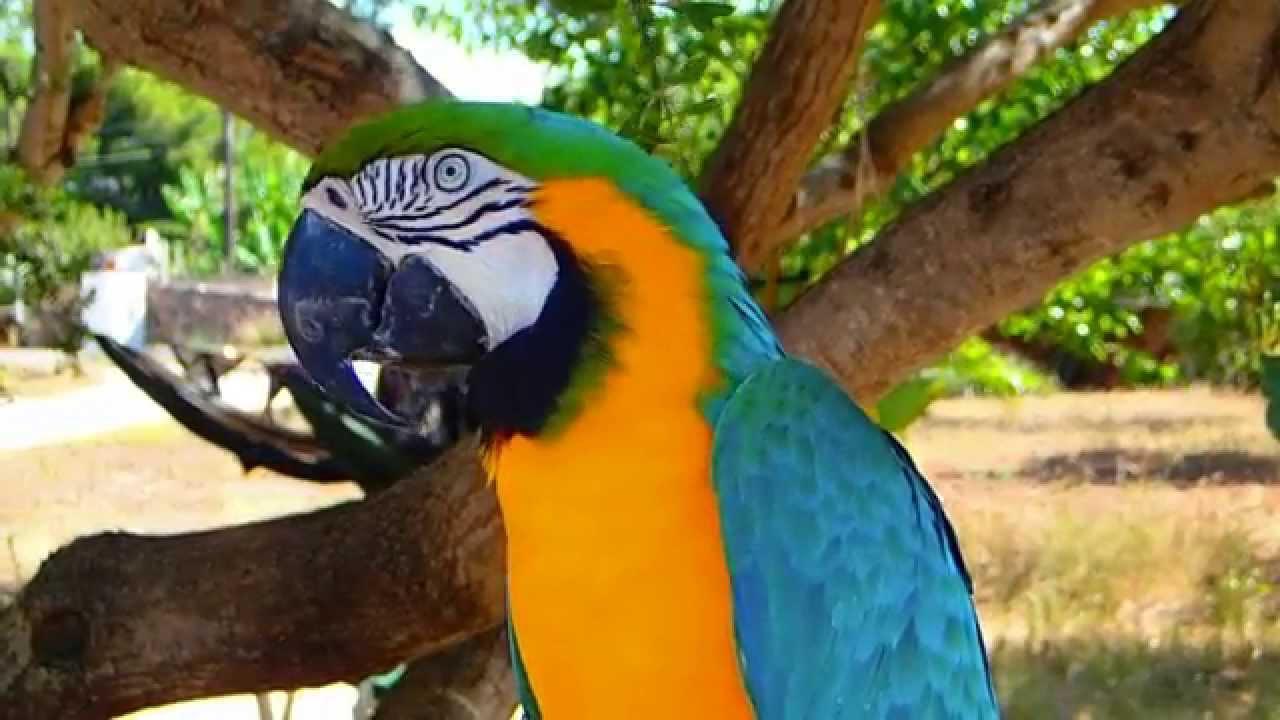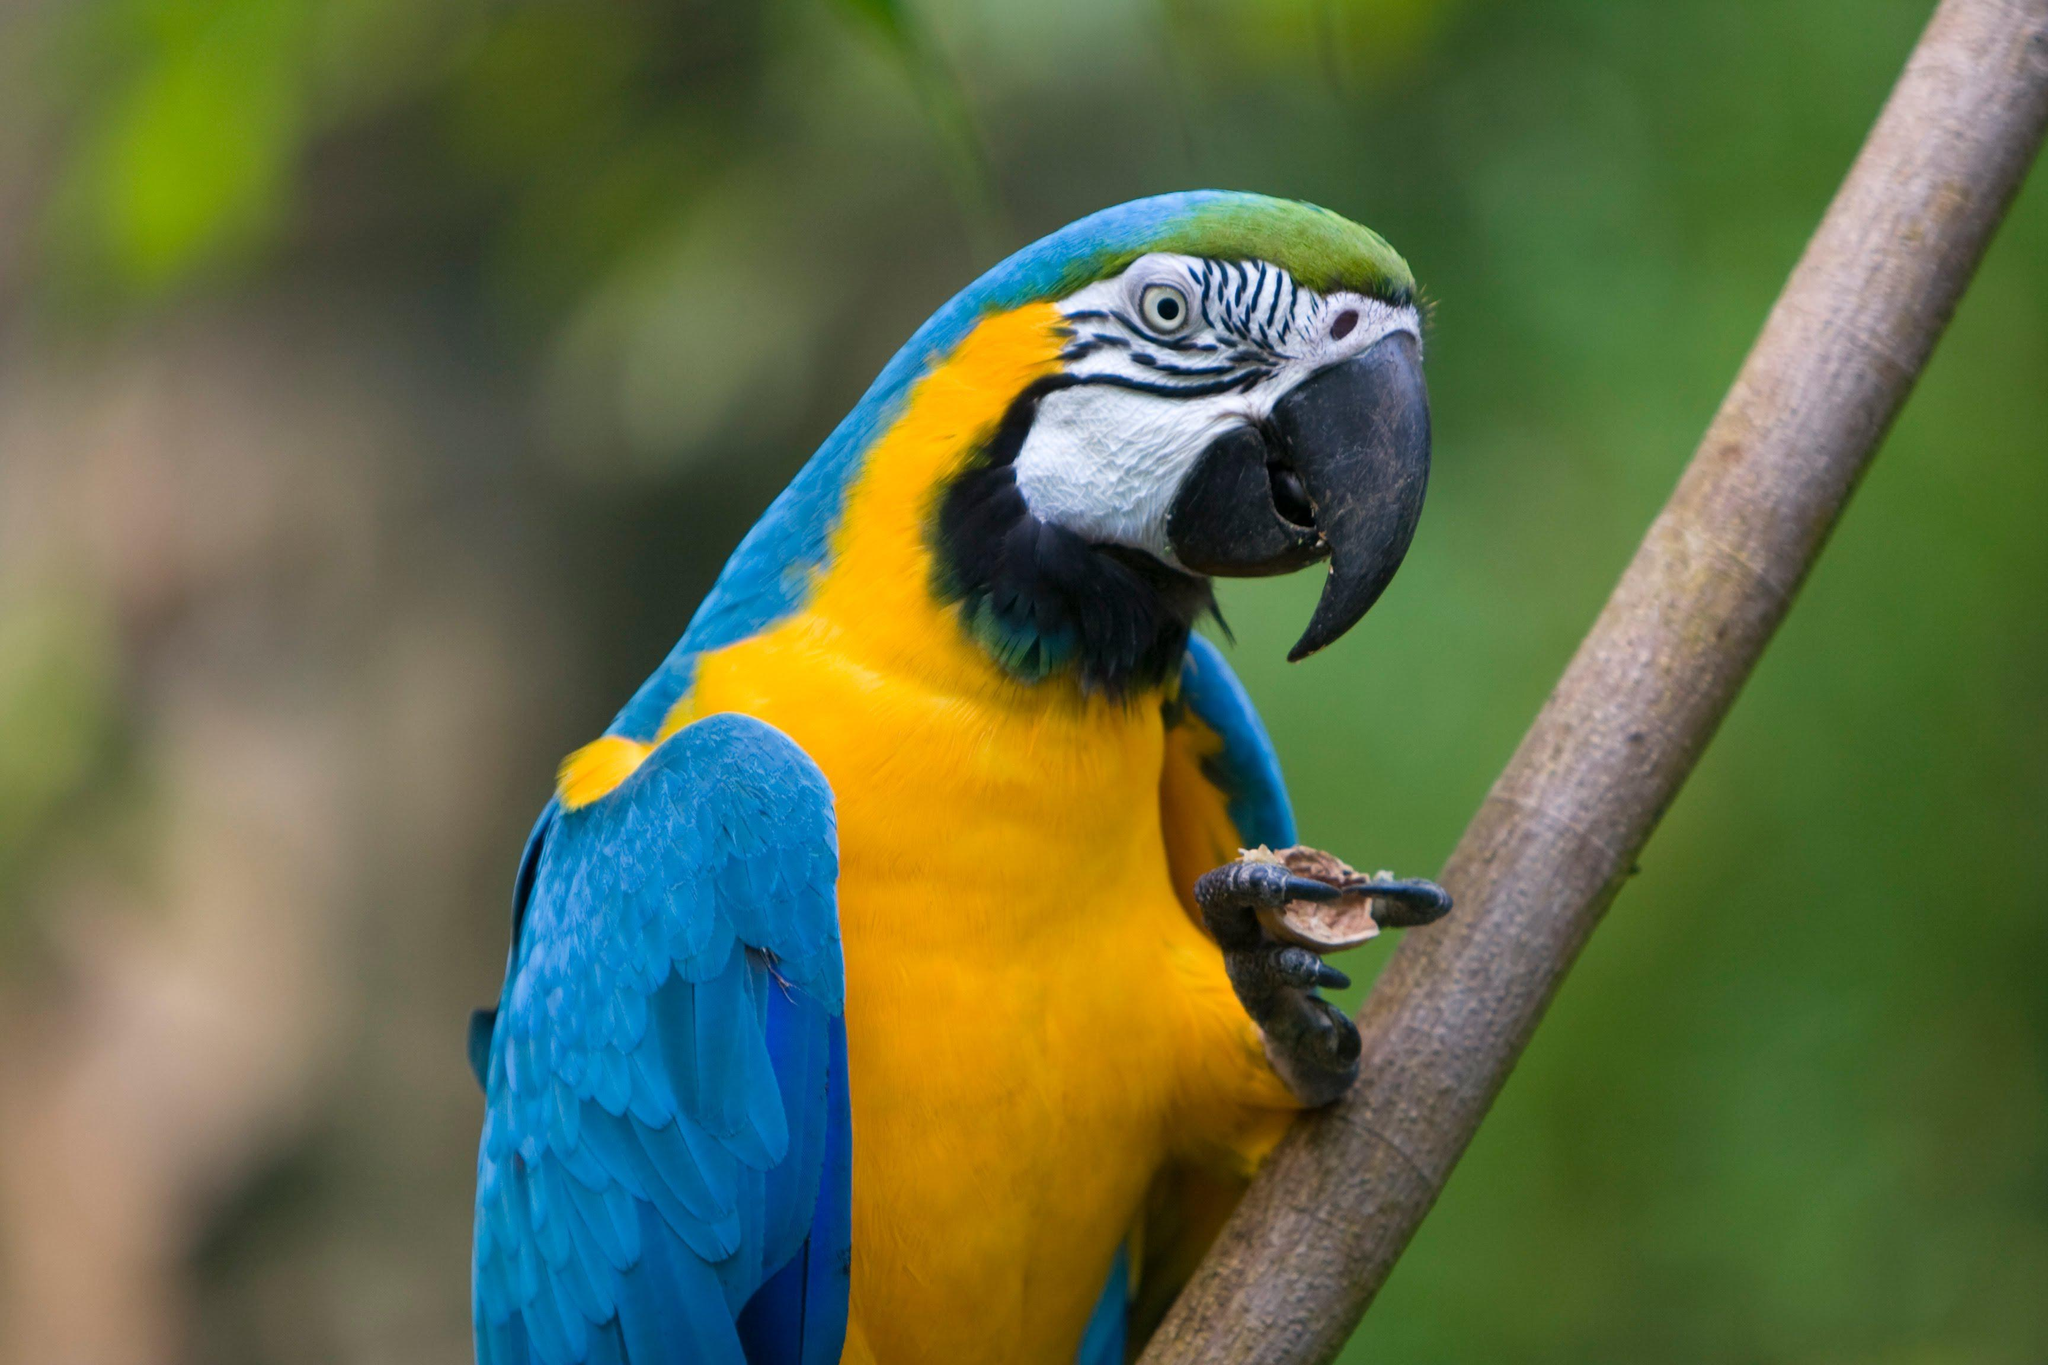The first image is the image on the left, the second image is the image on the right. Analyze the images presented: Is the assertion "There are plastic rings linked" valid? Answer yes or no. No. 